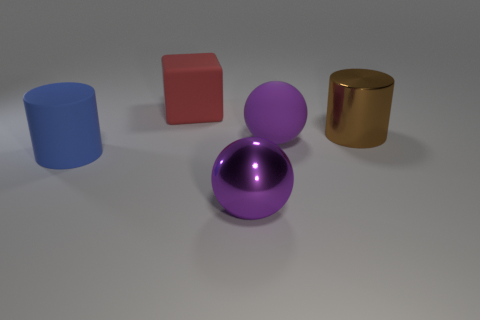How many blue rubber cylinders have the same size as the brown cylinder?
Give a very brief answer. 1. Do the large shiny cylinder and the metal sphere have the same color?
Keep it short and to the point. No. Is the cylinder right of the purple shiny object made of the same material as the cylinder that is in front of the big metallic cylinder?
Your answer should be compact. No. Are there more small gray shiny cylinders than purple matte things?
Offer a very short reply. No. Are there any other things of the same color as the large matte cube?
Offer a very short reply. No. Is the brown cylinder made of the same material as the cube?
Ensure brevity in your answer.  No. Is the number of brown metal objects less than the number of big cylinders?
Offer a terse response. Yes. Is the large brown metal object the same shape as the blue thing?
Make the answer very short. Yes. The shiny sphere is what color?
Your answer should be very brief. Purple. How many other objects are there of the same material as the brown object?
Ensure brevity in your answer.  1. 